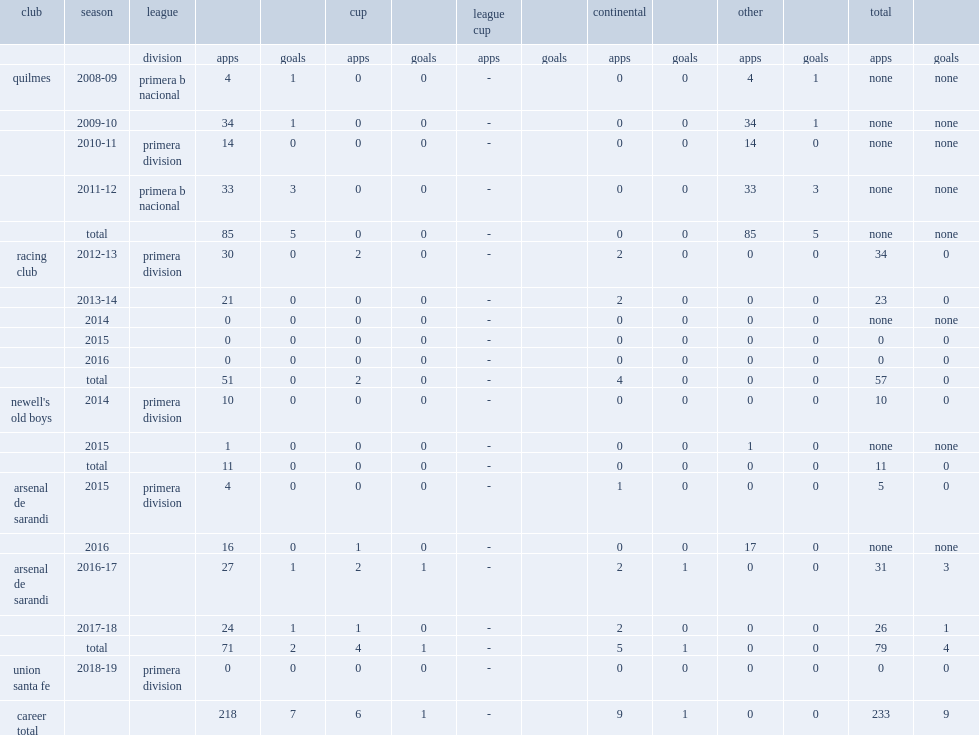In 2011-12, which club did claudio corvalan join in primera b nacional? Quilmes. 